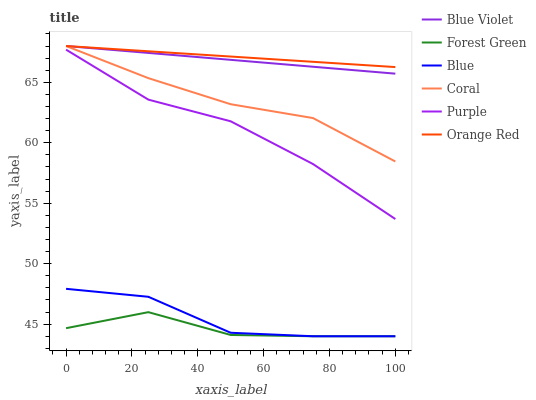Does Forest Green have the minimum area under the curve?
Answer yes or no. Yes. Does Orange Red have the maximum area under the curve?
Answer yes or no. Yes. Does Purple have the minimum area under the curve?
Answer yes or no. No. Does Purple have the maximum area under the curve?
Answer yes or no. No. Is Blue Violet the smoothest?
Answer yes or no. Yes. Is Blue the roughest?
Answer yes or no. Yes. Is Purple the smoothest?
Answer yes or no. No. Is Purple the roughest?
Answer yes or no. No. Does Purple have the lowest value?
Answer yes or no. No. Does Blue Violet have the highest value?
Answer yes or no. Yes. Does Purple have the highest value?
Answer yes or no. No. Is Blue less than Orange Red?
Answer yes or no. Yes. Is Coral greater than Blue?
Answer yes or no. Yes. Does Orange Red intersect Blue Violet?
Answer yes or no. Yes. Is Orange Red less than Blue Violet?
Answer yes or no. No. Is Orange Red greater than Blue Violet?
Answer yes or no. No. Does Blue intersect Orange Red?
Answer yes or no. No. 